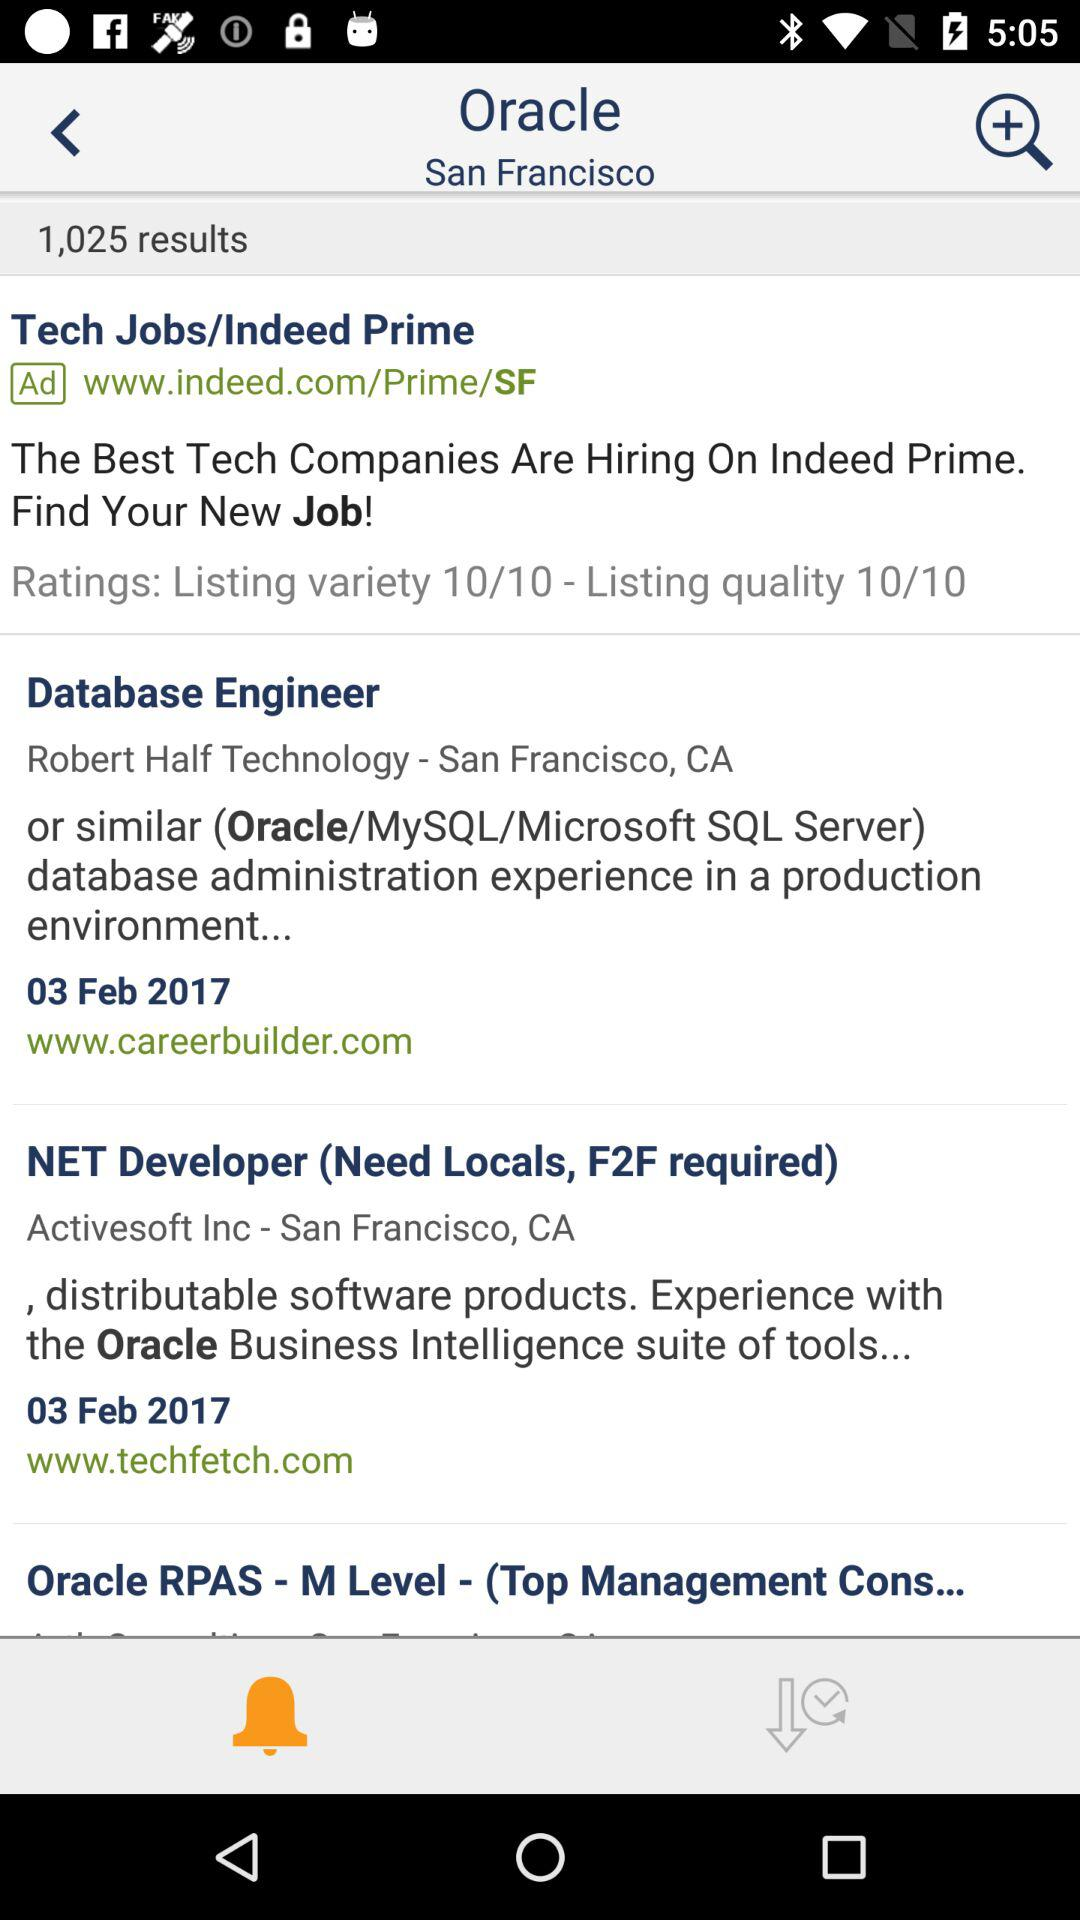How many results are there for the search "Oracle San Francisco"?
Answer the question using a single word or phrase. 1,025 